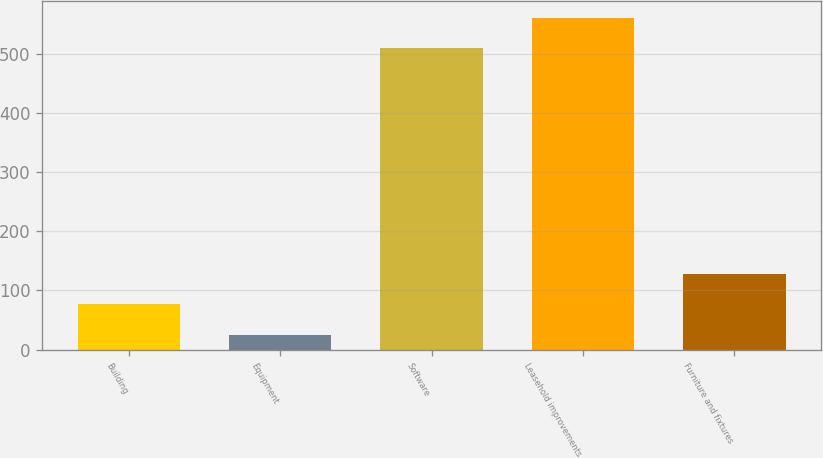<chart> <loc_0><loc_0><loc_500><loc_500><bar_chart><fcel>Building<fcel>Equipment<fcel>Software<fcel>Leasehold improvements<fcel>Furniture and fixtures<nl><fcel>76.5<fcel>25<fcel>510<fcel>561.5<fcel>128<nl></chart> 